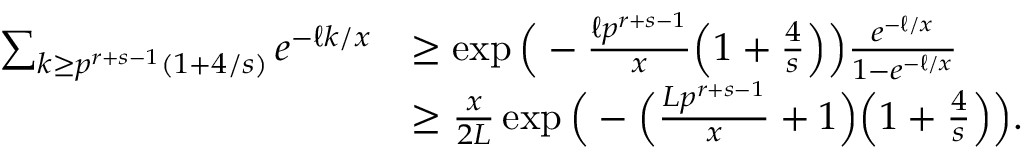<formula> <loc_0><loc_0><loc_500><loc_500>\begin{array} { r l } { \sum _ { k \geq p ^ { r + s - 1 } ( 1 + 4 / s ) } e ^ { - \ell k / x } } & { \geq \exp \left ( - \frac { \ell p ^ { r + s - 1 } } { x } \left ( 1 + \frac { 4 } { s } \right ) \right ) \frac { e ^ { - \ell / x } } { 1 - e ^ { - \ell / x } } } \\ & { \geq \frac { x } { 2 L } \exp \left ( - \left ( \frac { L p ^ { r + s - 1 } } { x } + 1 \right ) \left ( 1 + \frac { 4 } { s } \right ) \right ) . } \end{array}</formula> 